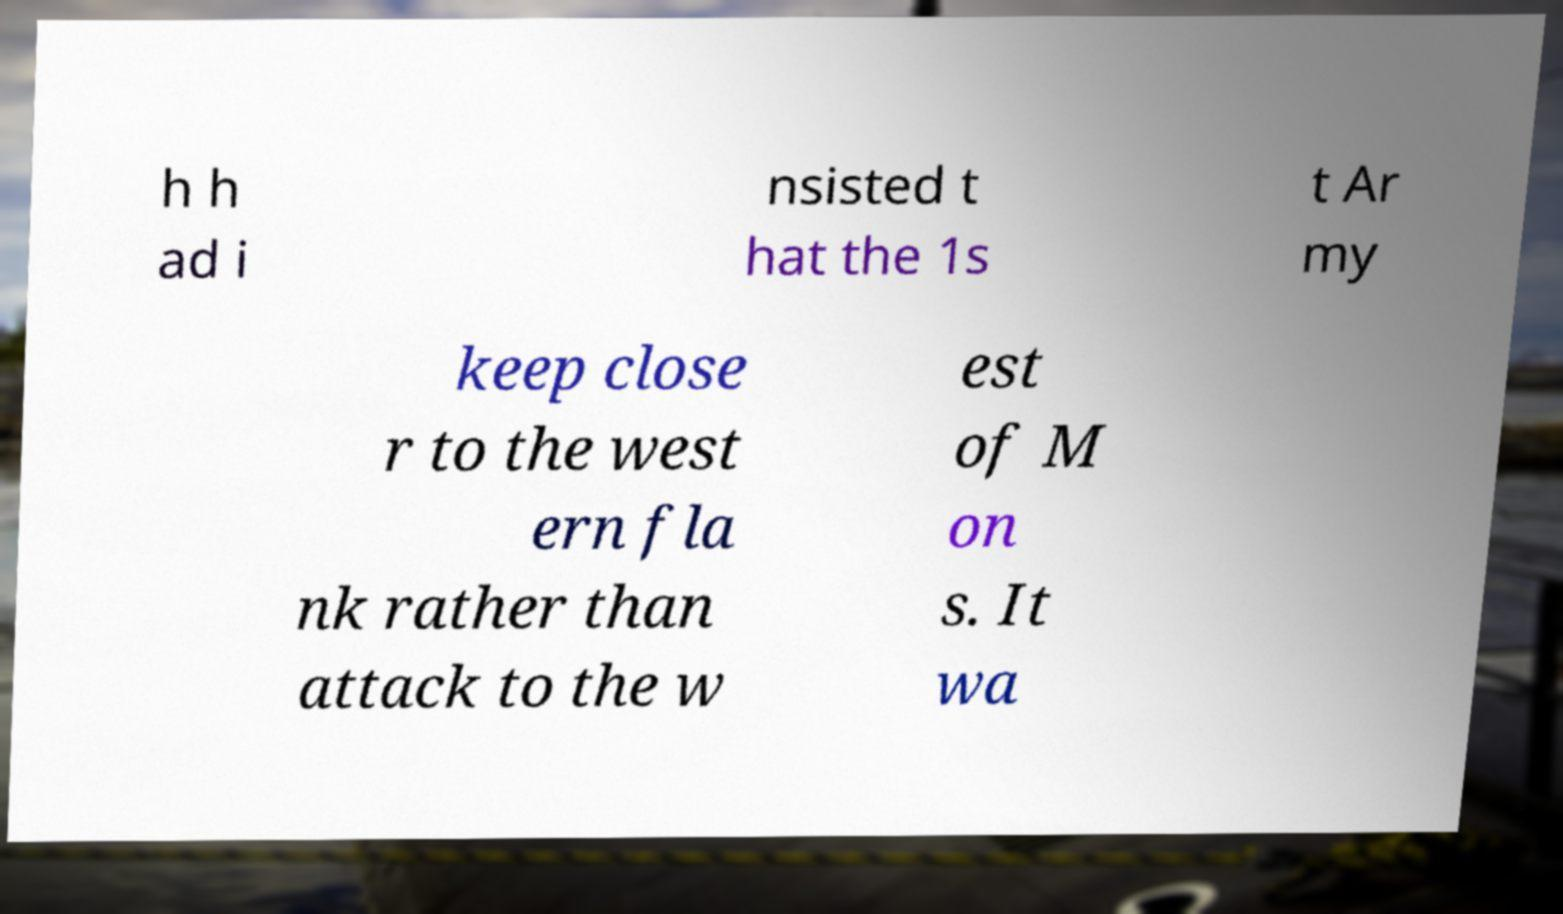Please identify and transcribe the text found in this image. h h ad i nsisted t hat the 1s t Ar my keep close r to the west ern fla nk rather than attack to the w est of M on s. It wa 